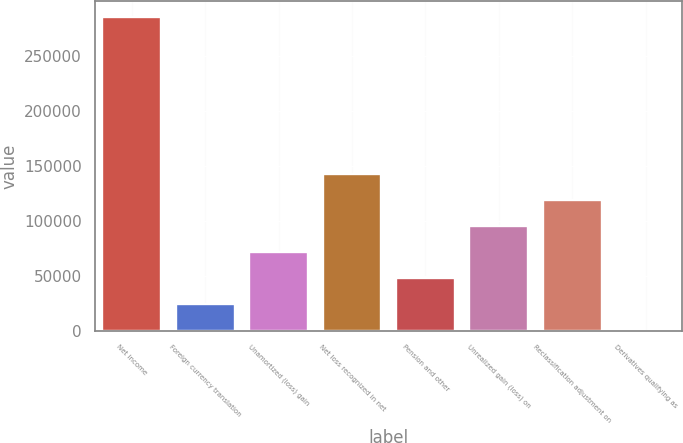<chart> <loc_0><loc_0><loc_500><loc_500><bar_chart><fcel>Net income<fcel>Foreign currency translation<fcel>Unamortized (loss) gain<fcel>Net loss recognized in net<fcel>Pension and other<fcel>Unrealized gain (loss) on<fcel>Reclassification adjustment on<fcel>Derivatives qualifying as<nl><fcel>285396<fcel>23844.4<fcel>71399.2<fcel>142731<fcel>47621.8<fcel>95176.6<fcel>118954<fcel>67<nl></chart> 